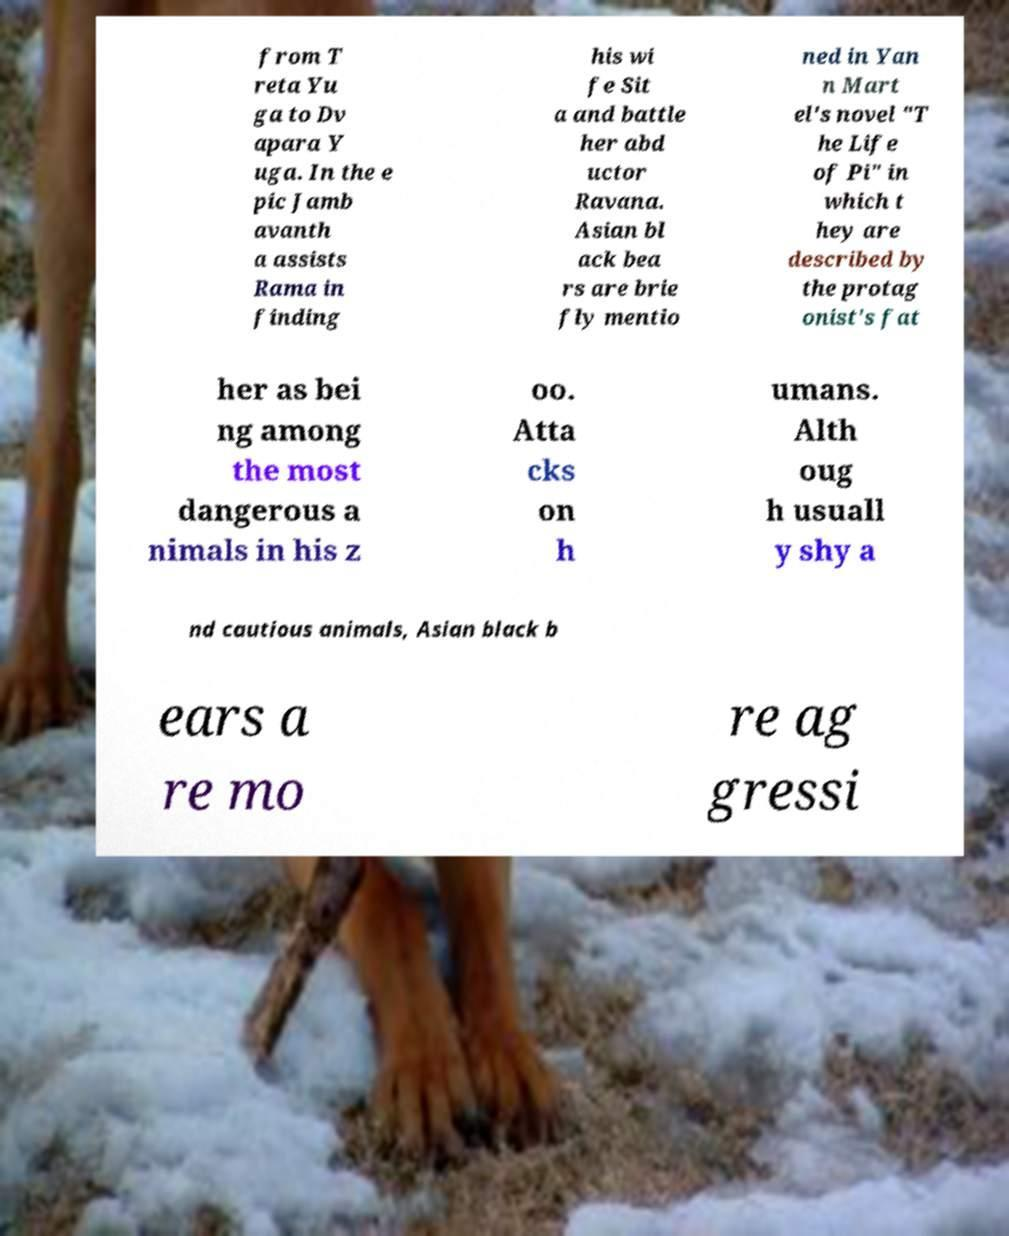I need the written content from this picture converted into text. Can you do that? from T reta Yu ga to Dv apara Y uga. In the e pic Jamb avanth a assists Rama in finding his wi fe Sit a and battle her abd uctor Ravana. Asian bl ack bea rs are brie fly mentio ned in Yan n Mart el's novel "T he Life of Pi" in which t hey are described by the protag onist's fat her as bei ng among the most dangerous a nimals in his z oo. Atta cks on h umans. Alth oug h usuall y shy a nd cautious animals, Asian black b ears a re mo re ag gressi 